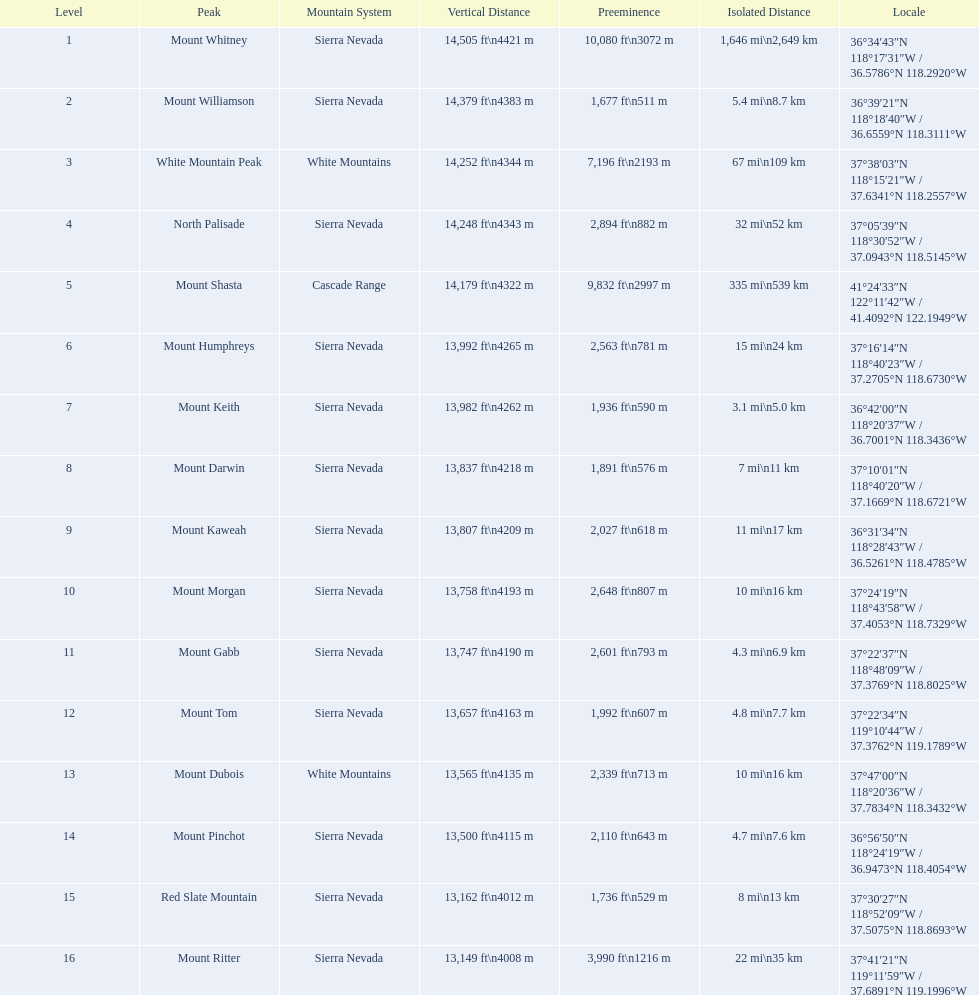Which are the mountain peaks? Mount Whitney, Mount Williamson, White Mountain Peak, North Palisade, Mount Shasta, Mount Humphreys, Mount Keith, Mount Darwin, Mount Kaweah, Mount Morgan, Mount Gabb, Mount Tom, Mount Dubois, Mount Pinchot, Red Slate Mountain, Mount Ritter. Of these, which is in the cascade range? Mount Shasta. 